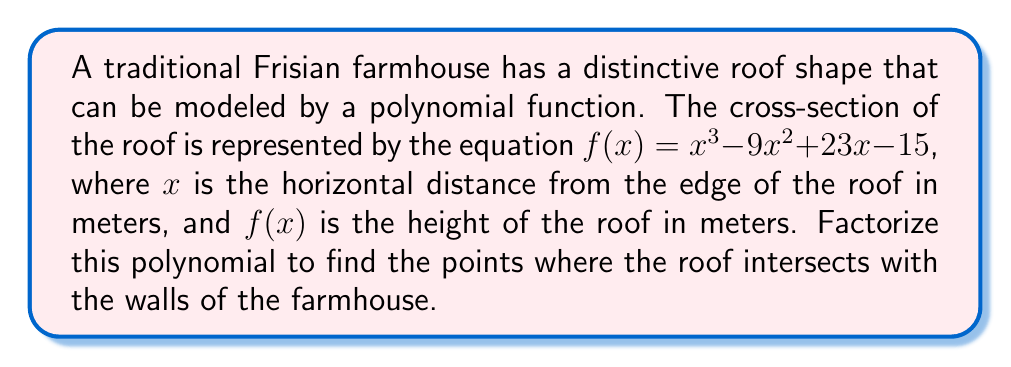Can you answer this question? To factorize the polynomial $f(x) = x^3 - 9x^2 + 23x - 15$, we'll follow these steps:

1) First, let's check if there's a common factor. In this case, there isn't one.

2) Next, we'll try to guess one root. A good strategy is to check factors of the constant term (15). The possible factors are ±1, ±3, ±5, ±15. 

   After trying these, we find that $f(1) = 1 - 9 + 23 - 15 = 0$. So, $(x-1)$ is a factor.

3) We can now use polynomial long division to divide $f(x)$ by $(x-1)$:

   $$\frac{x^3 - 9x^2 + 23x - 15}{x - 1} = x^2 - 8x + 15$$

4) The quadratic factor $x^2 - 8x + 15$ can be factored further:

   $x^2 - 8x + 15 = (x - 3)(x - 5)$

5) Therefore, the complete factorization is:

   $f(x) = (x - 1)(x - 3)(x - 5)$

The roots of this polynomial, which represent the points where the roof intersects the walls, are at $x = 1$, $x = 3$, and $x = 5$ meters from the edge of the roof.
Answer: $f(x) = (x - 1)(x - 3)(x - 5)$ 